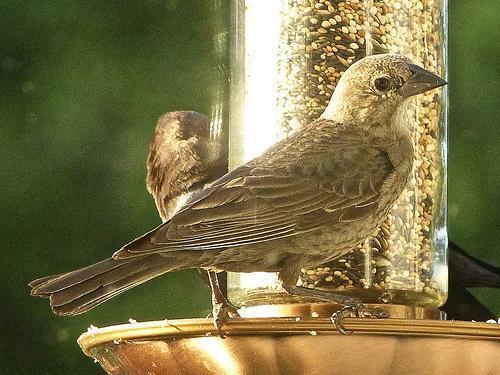How many birds are in the picture?
Give a very brief answer. 2. 